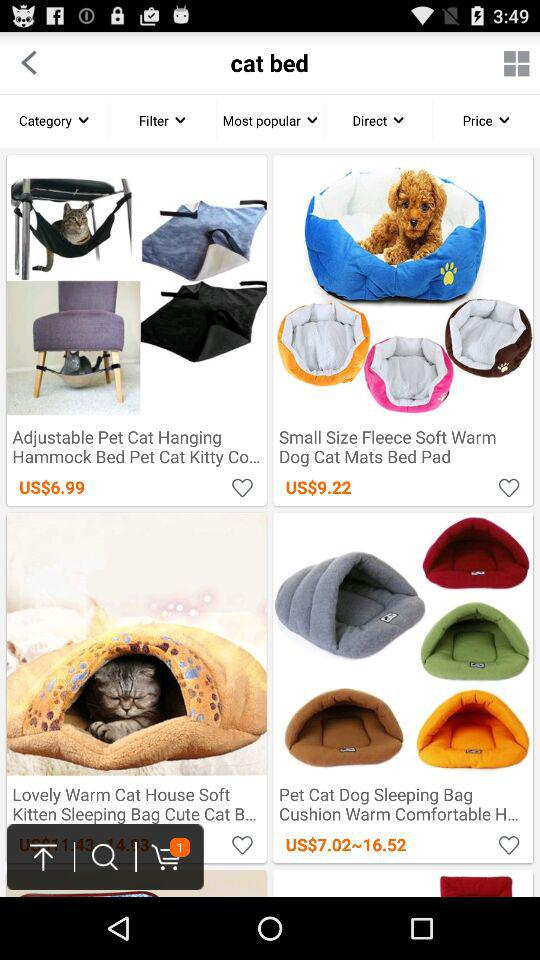How many items have prices above $10?
Answer the question using a single word or phrase. 2 